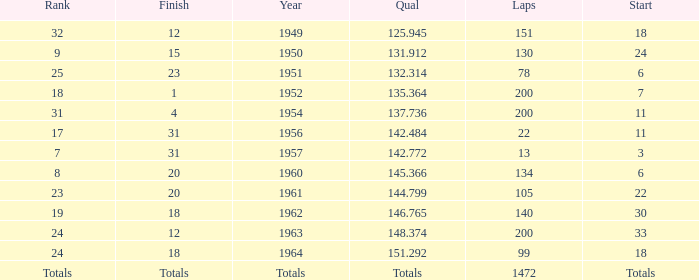Name the rank with finish of 12 and year of 1963 24.0. 